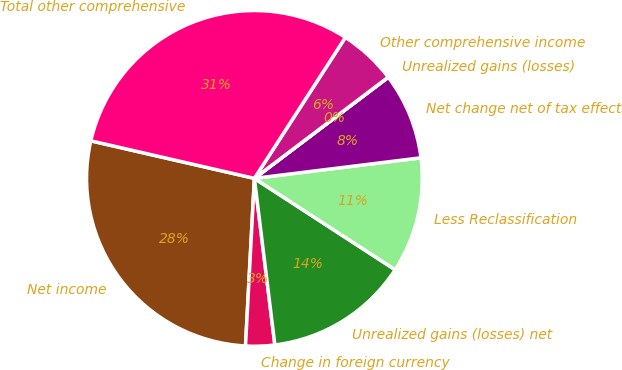Convert chart. <chart><loc_0><loc_0><loc_500><loc_500><pie_chart><fcel>Net income<fcel>Change in foreign currency<fcel>Unrealized gains (losses) net<fcel>Less Reclassification<fcel>Net change net of tax effect<fcel>Unrealized gains (losses)<fcel>Other comprehensive income<fcel>Total other comprehensive<nl><fcel>27.75%<fcel>2.79%<fcel>13.89%<fcel>11.12%<fcel>8.34%<fcel>0.01%<fcel>5.57%<fcel>30.53%<nl></chart> 